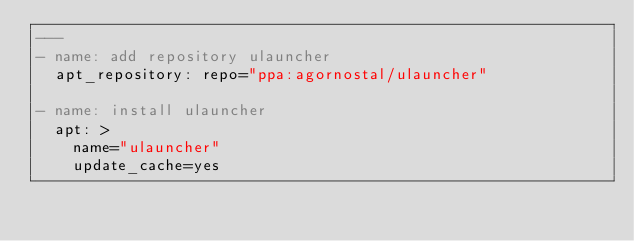<code> <loc_0><loc_0><loc_500><loc_500><_YAML_>---
- name: add repository ulauncher
  apt_repository: repo="ppa:agornostal/ulauncher"

- name: install ulauncher
  apt: >
    name="ulauncher"
    update_cache=yes
</code> 